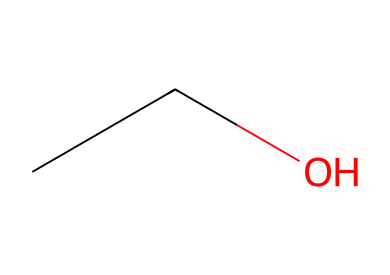What is the molecular formula of this compound? The compound has two carbon atoms (C), six hydrogen atoms (H), and one oxygen atom (O). This corresponds to the molecular formula C2H6O.
Answer: C2H6O How many carbon atoms are in the structure? By examining the structure, there are two carbon atoms present in the SMILES representation CC, which indicates two sequential carbon atoms.
Answer: 2 How many hydrogen atoms are bonded to the oxygen? The molecular arrangement shows the hydroxyl group (–OH) in the structure, where a single hydrogen atom is directly bonded to the oxygen atom.
Answer: 1 What type of molecule is ethanol classified as? Ethanol has a hydroxyl functional group (–OH) in its structure, indicating that it is classified as an alcohol.
Answer: alcohol Does this compound have polar characteristics? The presence of the hydroxyl group suggests that there is a significant electronegativity difference between the oxygen and hydrogen, making it polar due to the uneven distribution of electron density.
Answer: Yes What solvent properties does ethanol possess? Ethanol is known for its ability to dissolve both polar and non-polar substances due to its dual nature, allowing it to be used as a universal solvent in various applications.
Answer: Universal solvent 